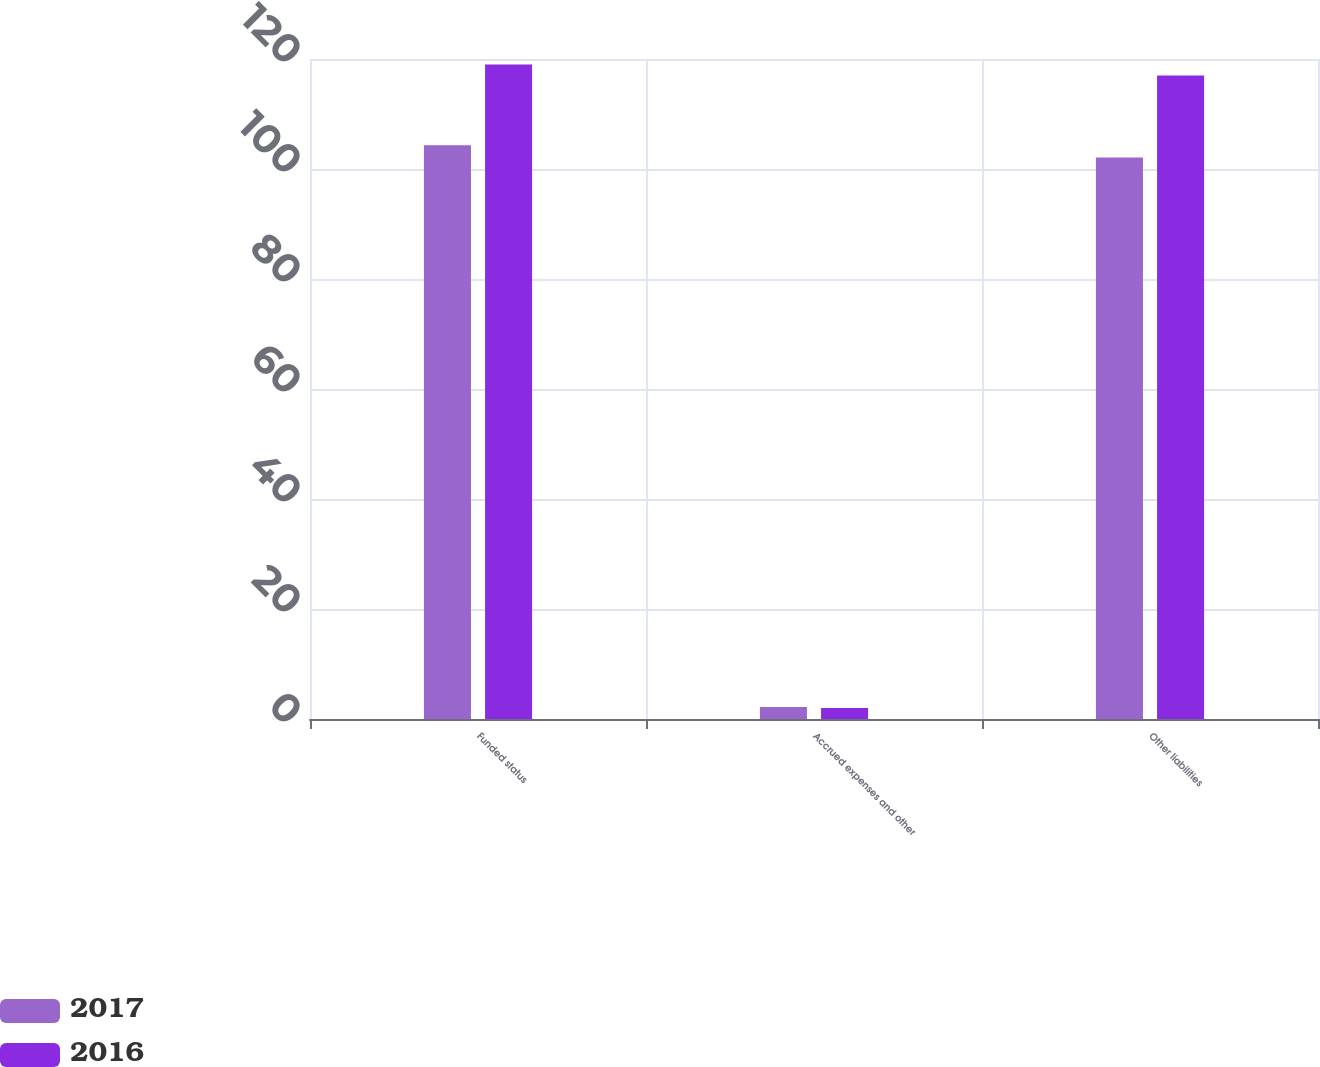<chart> <loc_0><loc_0><loc_500><loc_500><stacked_bar_chart><ecel><fcel>Funded status<fcel>Accrued expenses and other<fcel>Other liabilities<nl><fcel>2017<fcel>104.3<fcel>2.2<fcel>102.1<nl><fcel>2016<fcel>119<fcel>2<fcel>117<nl></chart> 